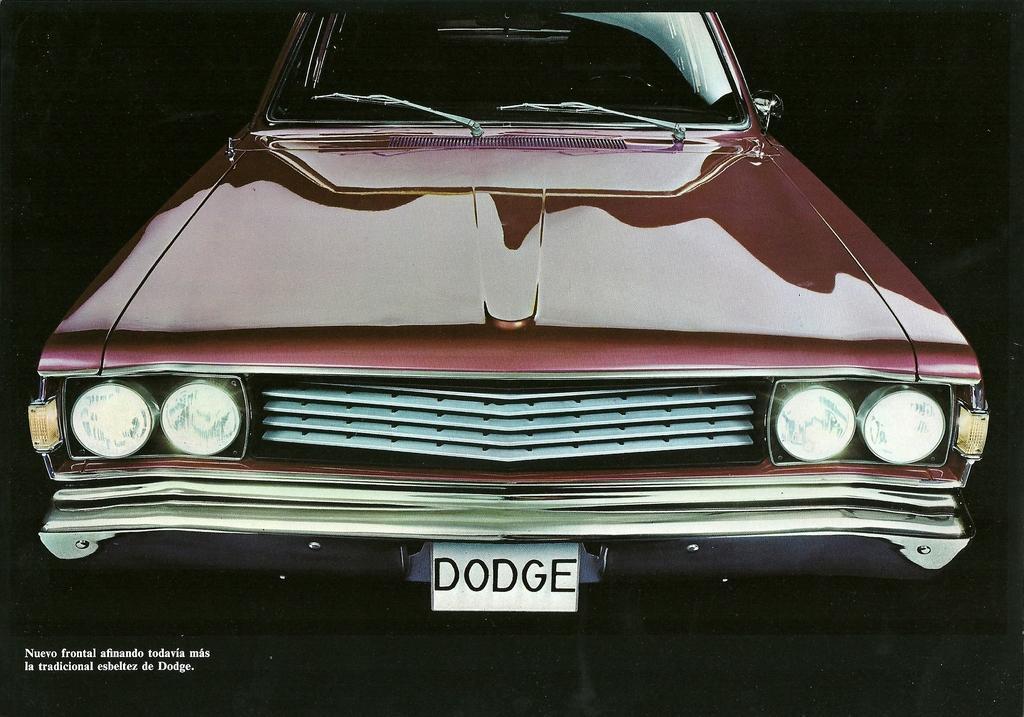Please provide a concise description of this image. In the center of the image we can see a car. In the bottom left corner we can see the text. In the background, the image is dark. 